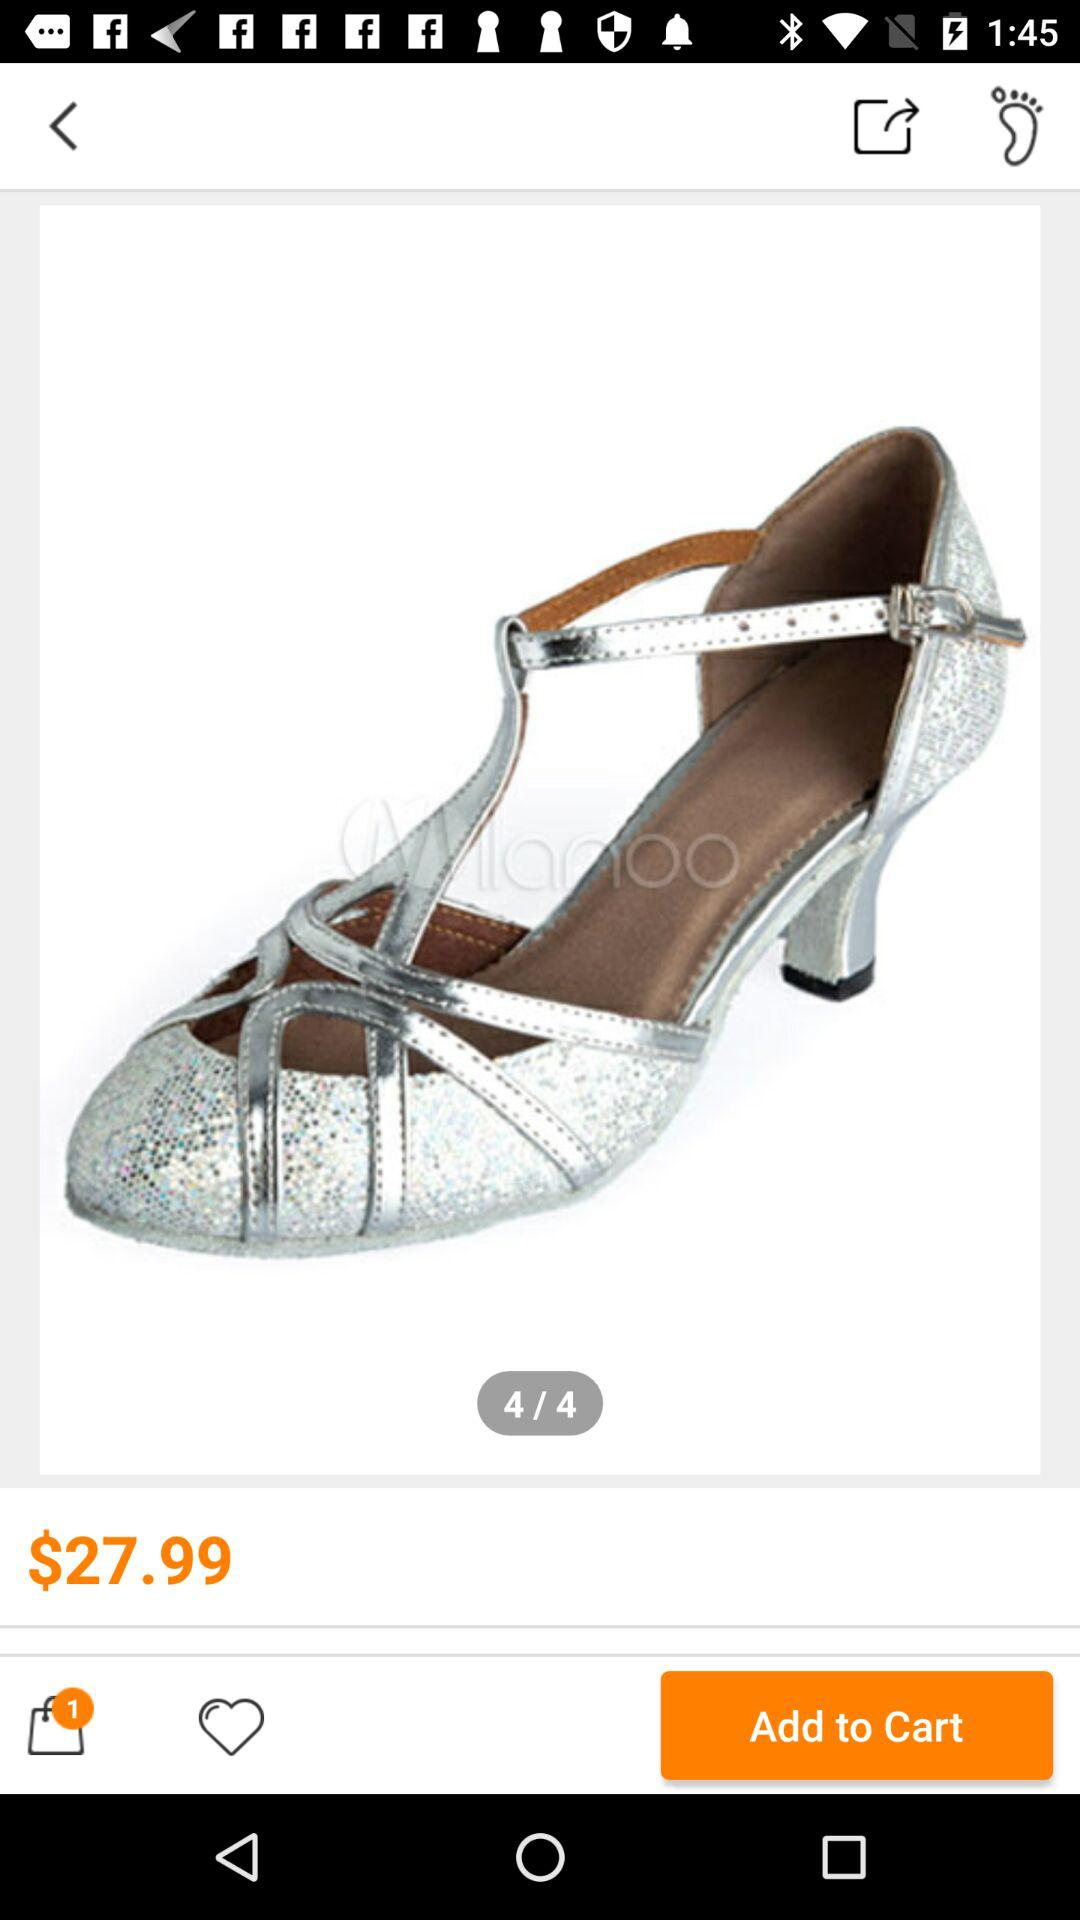Currently, which image number is open? The image number that is currently open is 4. 